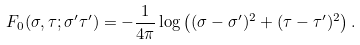<formula> <loc_0><loc_0><loc_500><loc_500>F _ { 0 } ( \sigma , \tau ; \sigma ^ { \prime } \tau ^ { \prime } ) = - \frac { 1 } { 4 \pi } \log \left ( ( \sigma - \sigma ^ { \prime } ) ^ { 2 } + ( \tau - \tau ^ { \prime } ) ^ { 2 } \right ) .</formula> 